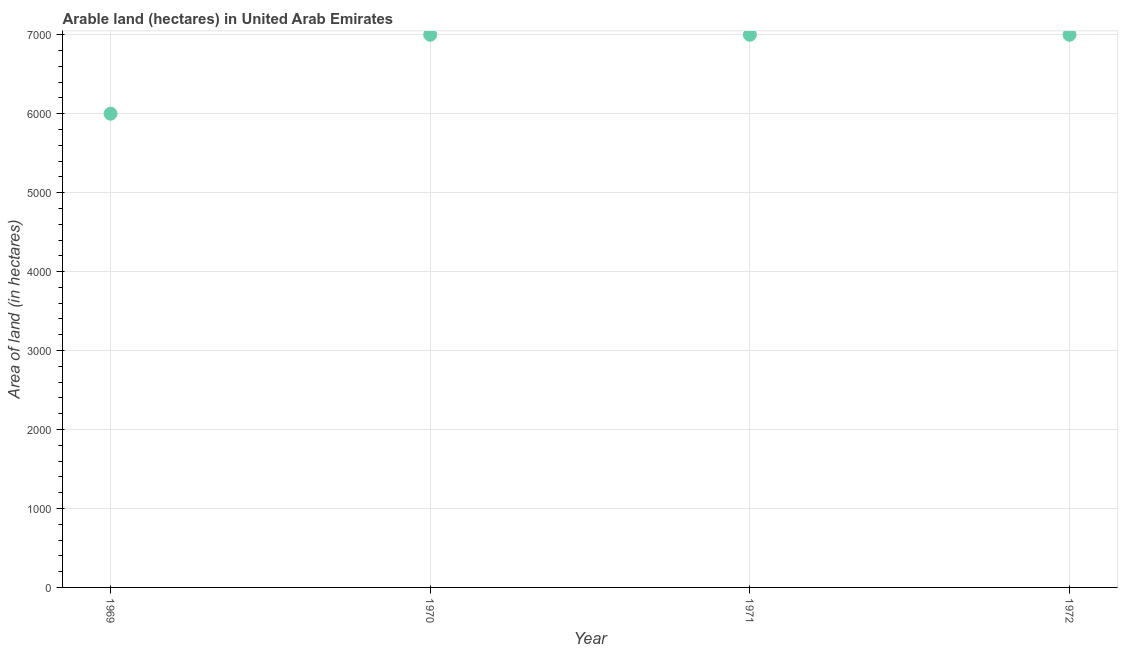What is the area of land in 1971?
Make the answer very short. 7000. Across all years, what is the maximum area of land?
Your response must be concise. 7000. Across all years, what is the minimum area of land?
Your response must be concise. 6000. In which year was the area of land minimum?
Offer a terse response. 1969. What is the sum of the area of land?
Keep it short and to the point. 2.70e+04. What is the difference between the area of land in 1969 and 1970?
Provide a succinct answer. -1000. What is the average area of land per year?
Ensure brevity in your answer.  6750. What is the median area of land?
Give a very brief answer. 7000. In how many years, is the area of land greater than 600 hectares?
Offer a terse response. 4. What is the ratio of the area of land in 1969 to that in 1971?
Make the answer very short. 0.86. What is the difference between the highest and the second highest area of land?
Offer a very short reply. 0. What is the difference between the highest and the lowest area of land?
Make the answer very short. 1000. Does the area of land monotonically increase over the years?
Give a very brief answer. No. How many dotlines are there?
Your response must be concise. 1. Are the values on the major ticks of Y-axis written in scientific E-notation?
Ensure brevity in your answer.  No. Does the graph contain grids?
Provide a short and direct response. Yes. What is the title of the graph?
Make the answer very short. Arable land (hectares) in United Arab Emirates. What is the label or title of the Y-axis?
Provide a short and direct response. Area of land (in hectares). What is the Area of land (in hectares) in 1969?
Ensure brevity in your answer.  6000. What is the Area of land (in hectares) in 1970?
Provide a short and direct response. 7000. What is the Area of land (in hectares) in 1971?
Offer a terse response. 7000. What is the Area of land (in hectares) in 1972?
Offer a terse response. 7000. What is the difference between the Area of land (in hectares) in 1969 and 1970?
Give a very brief answer. -1000. What is the difference between the Area of land (in hectares) in 1969 and 1971?
Offer a very short reply. -1000. What is the difference between the Area of land (in hectares) in 1969 and 1972?
Ensure brevity in your answer.  -1000. What is the difference between the Area of land (in hectares) in 1971 and 1972?
Offer a terse response. 0. What is the ratio of the Area of land (in hectares) in 1969 to that in 1970?
Ensure brevity in your answer.  0.86. What is the ratio of the Area of land (in hectares) in 1969 to that in 1971?
Your answer should be very brief. 0.86. What is the ratio of the Area of land (in hectares) in 1969 to that in 1972?
Ensure brevity in your answer.  0.86. 